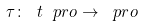<formula> <loc_0><loc_0><loc_500><loc_500>\tau \colon \ t { \ p r o } \rightarrow \ p r o</formula> 